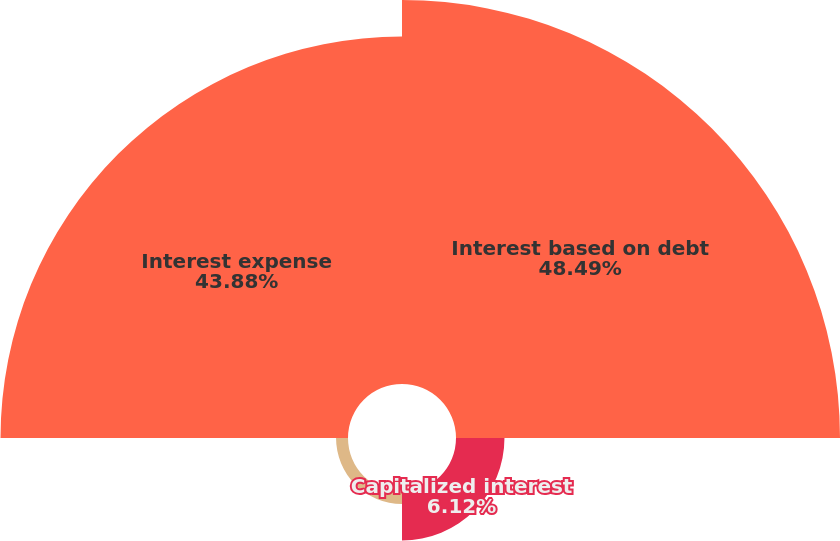<chart> <loc_0><loc_0><loc_500><loc_500><pie_chart><fcel>Interest based on debt<fcel>Capitalized interest<fcel>Other<fcel>Interest expense<nl><fcel>48.49%<fcel>6.12%<fcel>1.51%<fcel>43.88%<nl></chart> 